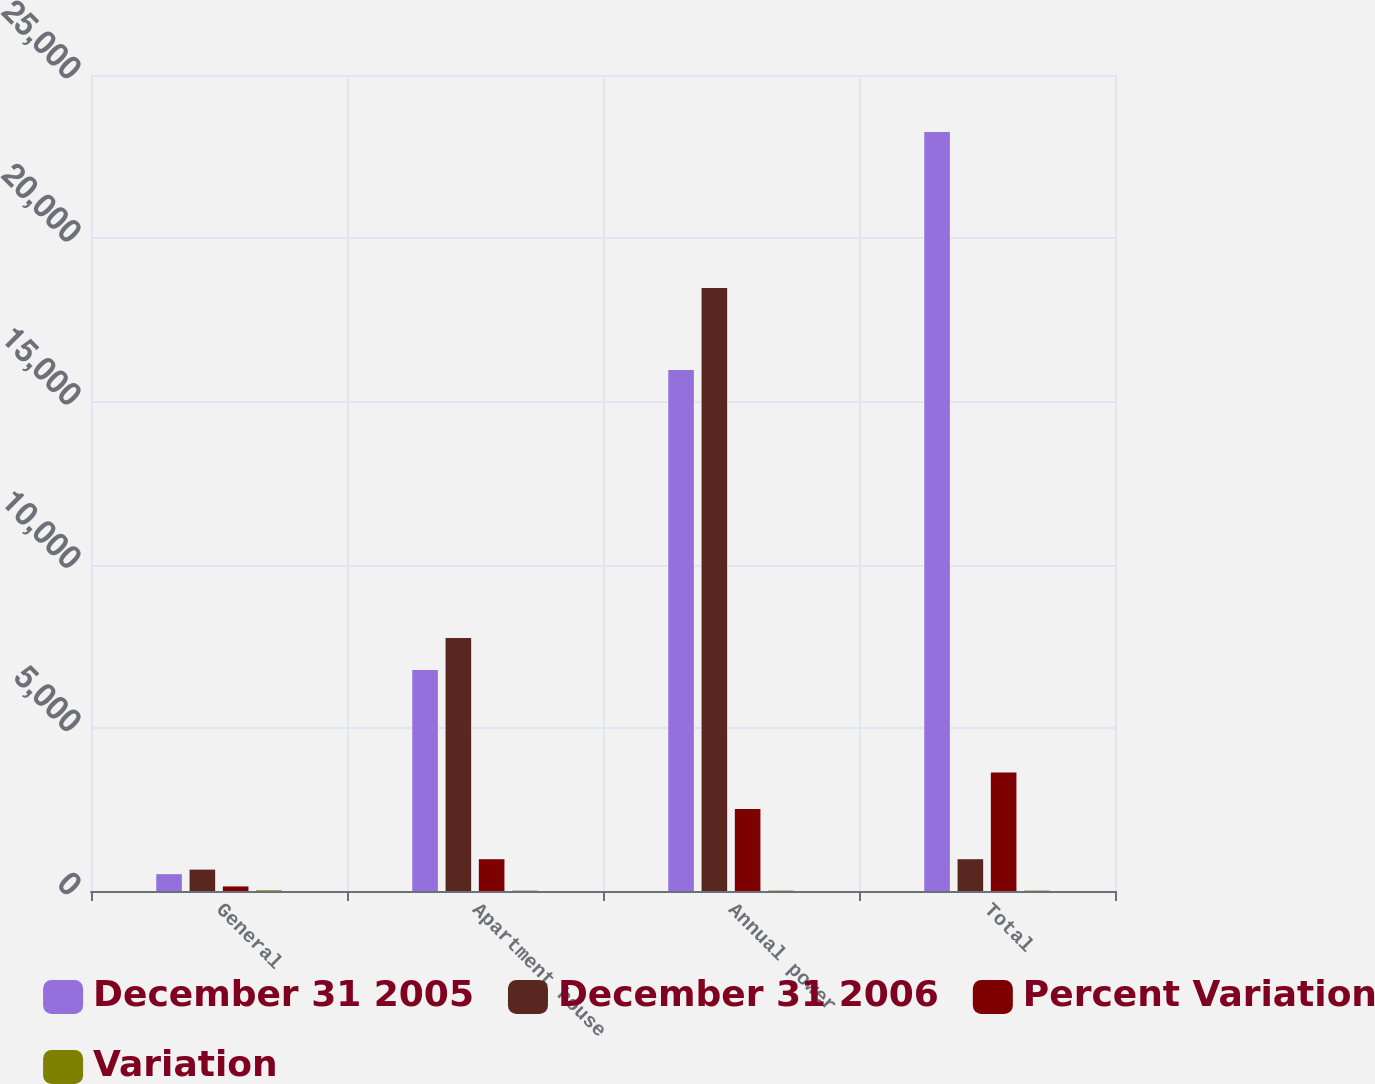Convert chart to OTSL. <chart><loc_0><loc_0><loc_500><loc_500><stacked_bar_chart><ecel><fcel>General<fcel>Apartment house<fcel>Annual power<fcel>Total<nl><fcel>December 31 2005<fcel>515<fcel>6774<fcel>15961<fcel>23250<nl><fcel>December 31 2006<fcel>655<fcel>7748<fcel>18474<fcel>974<nl><fcel>Percent Variation<fcel>140<fcel>974<fcel>2513<fcel>3627<nl><fcel>Variation<fcel>21.4<fcel>12.6<fcel>13.6<fcel>13.5<nl></chart> 